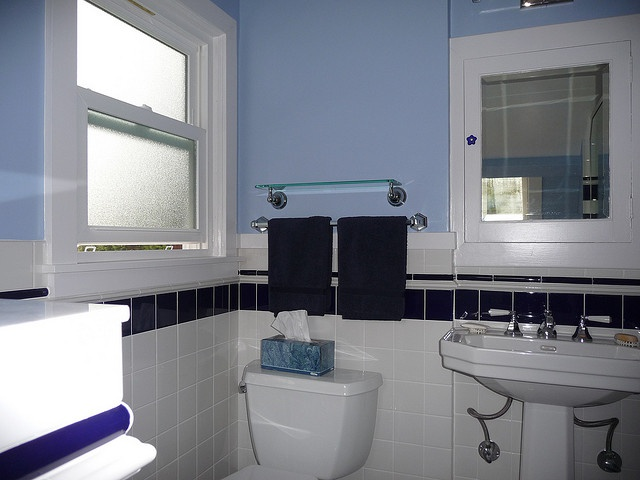Describe the objects in this image and their specific colors. I can see toilet in darkblue, darkgray, and gray tones and sink in darkblue, darkgray, gray, and black tones in this image. 